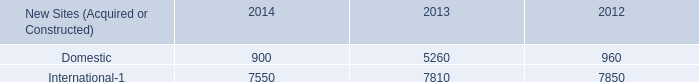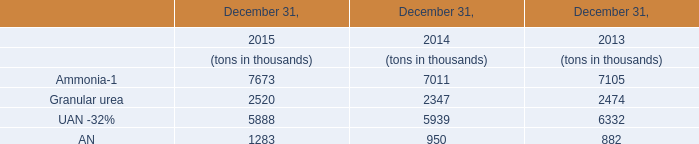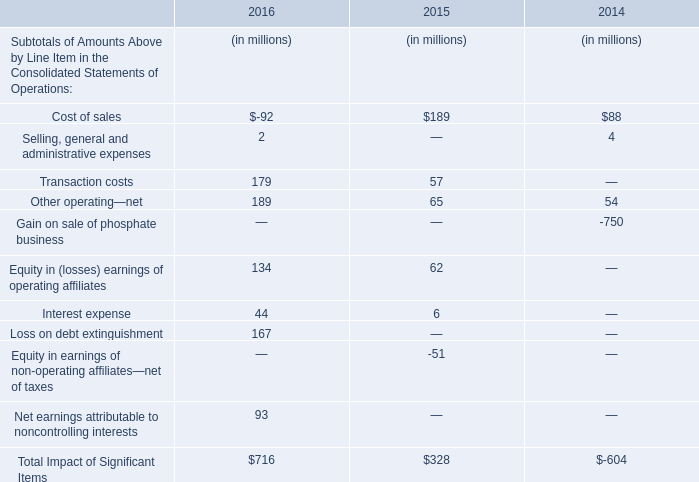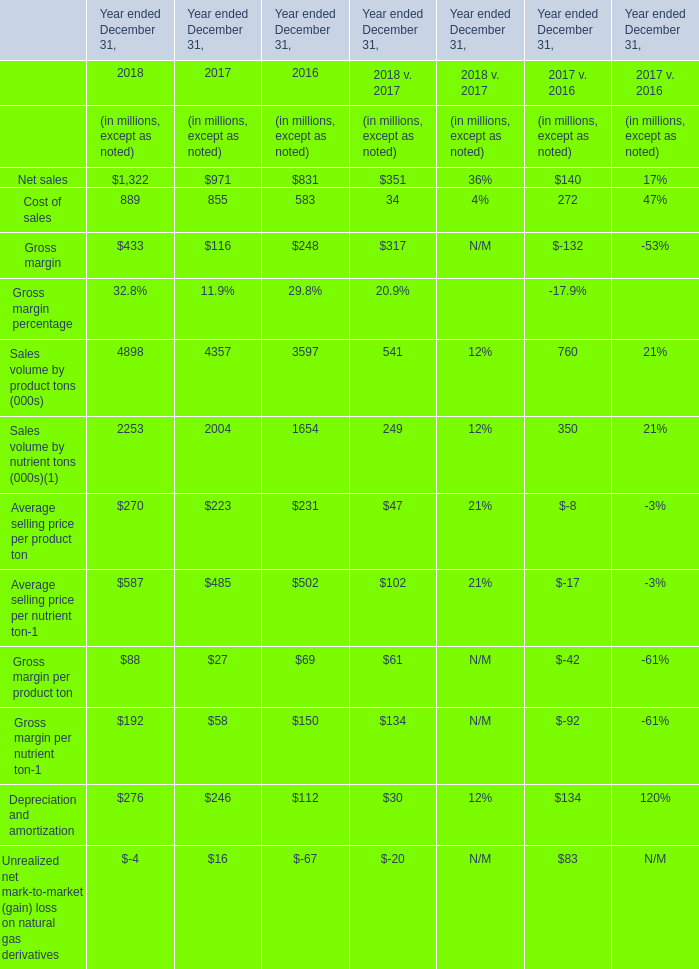in 2014 , how many of the new sites were forweign? 
Computations: (7550 / (900 + 7550))
Answer: 0.89349. 